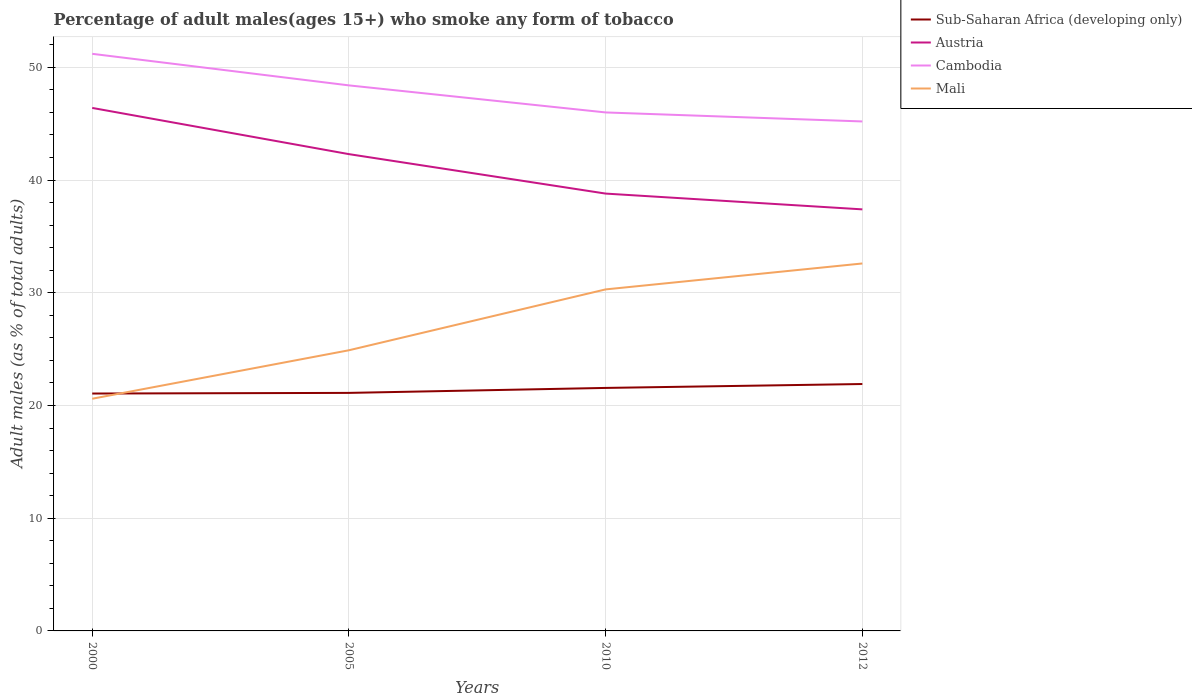Does the line corresponding to Mali intersect with the line corresponding to Cambodia?
Provide a short and direct response. No. Across all years, what is the maximum percentage of adult males who smoke in Sub-Saharan Africa (developing only)?
Ensure brevity in your answer.  21.06. What is the difference between the highest and the second highest percentage of adult males who smoke in Mali?
Ensure brevity in your answer.  12. What is the difference between two consecutive major ticks on the Y-axis?
Offer a very short reply. 10. Are the values on the major ticks of Y-axis written in scientific E-notation?
Offer a very short reply. No. Does the graph contain any zero values?
Your response must be concise. No. How many legend labels are there?
Ensure brevity in your answer.  4. What is the title of the graph?
Offer a very short reply. Percentage of adult males(ages 15+) who smoke any form of tobacco. What is the label or title of the Y-axis?
Give a very brief answer. Adult males (as % of total adults). What is the Adult males (as % of total adults) of Sub-Saharan Africa (developing only) in 2000?
Offer a terse response. 21.06. What is the Adult males (as % of total adults) in Austria in 2000?
Offer a terse response. 46.4. What is the Adult males (as % of total adults) in Cambodia in 2000?
Provide a succinct answer. 51.2. What is the Adult males (as % of total adults) in Mali in 2000?
Offer a terse response. 20.6. What is the Adult males (as % of total adults) of Sub-Saharan Africa (developing only) in 2005?
Your response must be concise. 21.12. What is the Adult males (as % of total adults) in Austria in 2005?
Offer a very short reply. 42.3. What is the Adult males (as % of total adults) in Cambodia in 2005?
Offer a very short reply. 48.4. What is the Adult males (as % of total adults) of Mali in 2005?
Give a very brief answer. 24.9. What is the Adult males (as % of total adults) of Sub-Saharan Africa (developing only) in 2010?
Make the answer very short. 21.56. What is the Adult males (as % of total adults) of Austria in 2010?
Give a very brief answer. 38.8. What is the Adult males (as % of total adults) in Mali in 2010?
Your answer should be very brief. 30.3. What is the Adult males (as % of total adults) in Sub-Saharan Africa (developing only) in 2012?
Ensure brevity in your answer.  21.91. What is the Adult males (as % of total adults) in Austria in 2012?
Ensure brevity in your answer.  37.4. What is the Adult males (as % of total adults) of Cambodia in 2012?
Your response must be concise. 45.2. What is the Adult males (as % of total adults) of Mali in 2012?
Make the answer very short. 32.6. Across all years, what is the maximum Adult males (as % of total adults) of Sub-Saharan Africa (developing only)?
Keep it short and to the point. 21.91. Across all years, what is the maximum Adult males (as % of total adults) in Austria?
Your response must be concise. 46.4. Across all years, what is the maximum Adult males (as % of total adults) in Cambodia?
Your response must be concise. 51.2. Across all years, what is the maximum Adult males (as % of total adults) in Mali?
Provide a short and direct response. 32.6. Across all years, what is the minimum Adult males (as % of total adults) in Sub-Saharan Africa (developing only)?
Your answer should be compact. 21.06. Across all years, what is the minimum Adult males (as % of total adults) of Austria?
Your response must be concise. 37.4. Across all years, what is the minimum Adult males (as % of total adults) in Cambodia?
Keep it short and to the point. 45.2. Across all years, what is the minimum Adult males (as % of total adults) of Mali?
Make the answer very short. 20.6. What is the total Adult males (as % of total adults) in Sub-Saharan Africa (developing only) in the graph?
Offer a very short reply. 85.64. What is the total Adult males (as % of total adults) in Austria in the graph?
Keep it short and to the point. 164.9. What is the total Adult males (as % of total adults) of Cambodia in the graph?
Give a very brief answer. 190.8. What is the total Adult males (as % of total adults) in Mali in the graph?
Offer a terse response. 108.4. What is the difference between the Adult males (as % of total adults) of Sub-Saharan Africa (developing only) in 2000 and that in 2005?
Offer a very short reply. -0.06. What is the difference between the Adult males (as % of total adults) in Cambodia in 2000 and that in 2005?
Offer a very short reply. 2.8. What is the difference between the Adult males (as % of total adults) in Sub-Saharan Africa (developing only) in 2000 and that in 2010?
Give a very brief answer. -0.5. What is the difference between the Adult males (as % of total adults) in Austria in 2000 and that in 2010?
Ensure brevity in your answer.  7.6. What is the difference between the Adult males (as % of total adults) of Cambodia in 2000 and that in 2010?
Ensure brevity in your answer.  5.2. What is the difference between the Adult males (as % of total adults) of Sub-Saharan Africa (developing only) in 2000 and that in 2012?
Offer a terse response. -0.85. What is the difference between the Adult males (as % of total adults) in Cambodia in 2000 and that in 2012?
Give a very brief answer. 6. What is the difference between the Adult males (as % of total adults) in Sub-Saharan Africa (developing only) in 2005 and that in 2010?
Give a very brief answer. -0.44. What is the difference between the Adult males (as % of total adults) of Mali in 2005 and that in 2010?
Keep it short and to the point. -5.4. What is the difference between the Adult males (as % of total adults) in Sub-Saharan Africa (developing only) in 2005 and that in 2012?
Provide a short and direct response. -0.79. What is the difference between the Adult males (as % of total adults) in Austria in 2005 and that in 2012?
Make the answer very short. 4.9. What is the difference between the Adult males (as % of total adults) of Cambodia in 2005 and that in 2012?
Your answer should be very brief. 3.2. What is the difference between the Adult males (as % of total adults) in Mali in 2005 and that in 2012?
Keep it short and to the point. -7.7. What is the difference between the Adult males (as % of total adults) of Sub-Saharan Africa (developing only) in 2010 and that in 2012?
Offer a terse response. -0.35. What is the difference between the Adult males (as % of total adults) of Cambodia in 2010 and that in 2012?
Ensure brevity in your answer.  0.8. What is the difference between the Adult males (as % of total adults) of Sub-Saharan Africa (developing only) in 2000 and the Adult males (as % of total adults) of Austria in 2005?
Your response must be concise. -21.24. What is the difference between the Adult males (as % of total adults) of Sub-Saharan Africa (developing only) in 2000 and the Adult males (as % of total adults) of Cambodia in 2005?
Offer a terse response. -27.34. What is the difference between the Adult males (as % of total adults) in Sub-Saharan Africa (developing only) in 2000 and the Adult males (as % of total adults) in Mali in 2005?
Give a very brief answer. -3.84. What is the difference between the Adult males (as % of total adults) in Cambodia in 2000 and the Adult males (as % of total adults) in Mali in 2005?
Offer a terse response. 26.3. What is the difference between the Adult males (as % of total adults) in Sub-Saharan Africa (developing only) in 2000 and the Adult males (as % of total adults) in Austria in 2010?
Offer a terse response. -17.74. What is the difference between the Adult males (as % of total adults) of Sub-Saharan Africa (developing only) in 2000 and the Adult males (as % of total adults) of Cambodia in 2010?
Your answer should be compact. -24.94. What is the difference between the Adult males (as % of total adults) in Sub-Saharan Africa (developing only) in 2000 and the Adult males (as % of total adults) in Mali in 2010?
Offer a terse response. -9.24. What is the difference between the Adult males (as % of total adults) of Cambodia in 2000 and the Adult males (as % of total adults) of Mali in 2010?
Offer a terse response. 20.9. What is the difference between the Adult males (as % of total adults) of Sub-Saharan Africa (developing only) in 2000 and the Adult males (as % of total adults) of Austria in 2012?
Offer a very short reply. -16.34. What is the difference between the Adult males (as % of total adults) of Sub-Saharan Africa (developing only) in 2000 and the Adult males (as % of total adults) of Cambodia in 2012?
Your answer should be compact. -24.14. What is the difference between the Adult males (as % of total adults) of Sub-Saharan Africa (developing only) in 2000 and the Adult males (as % of total adults) of Mali in 2012?
Offer a very short reply. -11.54. What is the difference between the Adult males (as % of total adults) in Austria in 2000 and the Adult males (as % of total adults) in Cambodia in 2012?
Give a very brief answer. 1.2. What is the difference between the Adult males (as % of total adults) in Austria in 2000 and the Adult males (as % of total adults) in Mali in 2012?
Keep it short and to the point. 13.8. What is the difference between the Adult males (as % of total adults) of Cambodia in 2000 and the Adult males (as % of total adults) of Mali in 2012?
Provide a short and direct response. 18.6. What is the difference between the Adult males (as % of total adults) of Sub-Saharan Africa (developing only) in 2005 and the Adult males (as % of total adults) of Austria in 2010?
Offer a terse response. -17.68. What is the difference between the Adult males (as % of total adults) in Sub-Saharan Africa (developing only) in 2005 and the Adult males (as % of total adults) in Cambodia in 2010?
Keep it short and to the point. -24.88. What is the difference between the Adult males (as % of total adults) of Sub-Saharan Africa (developing only) in 2005 and the Adult males (as % of total adults) of Mali in 2010?
Your answer should be very brief. -9.18. What is the difference between the Adult males (as % of total adults) in Austria in 2005 and the Adult males (as % of total adults) in Cambodia in 2010?
Offer a terse response. -3.7. What is the difference between the Adult males (as % of total adults) in Austria in 2005 and the Adult males (as % of total adults) in Mali in 2010?
Offer a very short reply. 12. What is the difference between the Adult males (as % of total adults) of Sub-Saharan Africa (developing only) in 2005 and the Adult males (as % of total adults) of Austria in 2012?
Provide a succinct answer. -16.28. What is the difference between the Adult males (as % of total adults) in Sub-Saharan Africa (developing only) in 2005 and the Adult males (as % of total adults) in Cambodia in 2012?
Your answer should be very brief. -24.08. What is the difference between the Adult males (as % of total adults) of Sub-Saharan Africa (developing only) in 2005 and the Adult males (as % of total adults) of Mali in 2012?
Provide a succinct answer. -11.48. What is the difference between the Adult males (as % of total adults) in Cambodia in 2005 and the Adult males (as % of total adults) in Mali in 2012?
Your answer should be very brief. 15.8. What is the difference between the Adult males (as % of total adults) in Sub-Saharan Africa (developing only) in 2010 and the Adult males (as % of total adults) in Austria in 2012?
Your response must be concise. -15.84. What is the difference between the Adult males (as % of total adults) of Sub-Saharan Africa (developing only) in 2010 and the Adult males (as % of total adults) of Cambodia in 2012?
Offer a very short reply. -23.64. What is the difference between the Adult males (as % of total adults) of Sub-Saharan Africa (developing only) in 2010 and the Adult males (as % of total adults) of Mali in 2012?
Your answer should be very brief. -11.04. What is the difference between the Adult males (as % of total adults) in Cambodia in 2010 and the Adult males (as % of total adults) in Mali in 2012?
Offer a very short reply. 13.4. What is the average Adult males (as % of total adults) of Sub-Saharan Africa (developing only) per year?
Provide a succinct answer. 21.41. What is the average Adult males (as % of total adults) of Austria per year?
Offer a terse response. 41.23. What is the average Adult males (as % of total adults) in Cambodia per year?
Provide a short and direct response. 47.7. What is the average Adult males (as % of total adults) of Mali per year?
Keep it short and to the point. 27.1. In the year 2000, what is the difference between the Adult males (as % of total adults) of Sub-Saharan Africa (developing only) and Adult males (as % of total adults) of Austria?
Your answer should be compact. -25.34. In the year 2000, what is the difference between the Adult males (as % of total adults) of Sub-Saharan Africa (developing only) and Adult males (as % of total adults) of Cambodia?
Your answer should be compact. -30.14. In the year 2000, what is the difference between the Adult males (as % of total adults) in Sub-Saharan Africa (developing only) and Adult males (as % of total adults) in Mali?
Provide a succinct answer. 0.46. In the year 2000, what is the difference between the Adult males (as % of total adults) of Austria and Adult males (as % of total adults) of Cambodia?
Keep it short and to the point. -4.8. In the year 2000, what is the difference between the Adult males (as % of total adults) in Austria and Adult males (as % of total adults) in Mali?
Provide a succinct answer. 25.8. In the year 2000, what is the difference between the Adult males (as % of total adults) in Cambodia and Adult males (as % of total adults) in Mali?
Provide a succinct answer. 30.6. In the year 2005, what is the difference between the Adult males (as % of total adults) in Sub-Saharan Africa (developing only) and Adult males (as % of total adults) in Austria?
Your answer should be compact. -21.18. In the year 2005, what is the difference between the Adult males (as % of total adults) of Sub-Saharan Africa (developing only) and Adult males (as % of total adults) of Cambodia?
Ensure brevity in your answer.  -27.28. In the year 2005, what is the difference between the Adult males (as % of total adults) of Sub-Saharan Africa (developing only) and Adult males (as % of total adults) of Mali?
Keep it short and to the point. -3.78. In the year 2005, what is the difference between the Adult males (as % of total adults) in Austria and Adult males (as % of total adults) in Cambodia?
Your response must be concise. -6.1. In the year 2005, what is the difference between the Adult males (as % of total adults) of Austria and Adult males (as % of total adults) of Mali?
Offer a very short reply. 17.4. In the year 2005, what is the difference between the Adult males (as % of total adults) of Cambodia and Adult males (as % of total adults) of Mali?
Ensure brevity in your answer.  23.5. In the year 2010, what is the difference between the Adult males (as % of total adults) in Sub-Saharan Africa (developing only) and Adult males (as % of total adults) in Austria?
Your response must be concise. -17.24. In the year 2010, what is the difference between the Adult males (as % of total adults) in Sub-Saharan Africa (developing only) and Adult males (as % of total adults) in Cambodia?
Offer a very short reply. -24.44. In the year 2010, what is the difference between the Adult males (as % of total adults) in Sub-Saharan Africa (developing only) and Adult males (as % of total adults) in Mali?
Ensure brevity in your answer.  -8.74. In the year 2010, what is the difference between the Adult males (as % of total adults) of Austria and Adult males (as % of total adults) of Mali?
Provide a succinct answer. 8.5. In the year 2010, what is the difference between the Adult males (as % of total adults) of Cambodia and Adult males (as % of total adults) of Mali?
Provide a short and direct response. 15.7. In the year 2012, what is the difference between the Adult males (as % of total adults) of Sub-Saharan Africa (developing only) and Adult males (as % of total adults) of Austria?
Provide a succinct answer. -15.49. In the year 2012, what is the difference between the Adult males (as % of total adults) of Sub-Saharan Africa (developing only) and Adult males (as % of total adults) of Cambodia?
Your response must be concise. -23.29. In the year 2012, what is the difference between the Adult males (as % of total adults) in Sub-Saharan Africa (developing only) and Adult males (as % of total adults) in Mali?
Your answer should be very brief. -10.69. In the year 2012, what is the difference between the Adult males (as % of total adults) of Cambodia and Adult males (as % of total adults) of Mali?
Your response must be concise. 12.6. What is the ratio of the Adult males (as % of total adults) in Sub-Saharan Africa (developing only) in 2000 to that in 2005?
Your response must be concise. 1. What is the ratio of the Adult males (as % of total adults) of Austria in 2000 to that in 2005?
Offer a very short reply. 1.1. What is the ratio of the Adult males (as % of total adults) in Cambodia in 2000 to that in 2005?
Provide a short and direct response. 1.06. What is the ratio of the Adult males (as % of total adults) in Mali in 2000 to that in 2005?
Give a very brief answer. 0.83. What is the ratio of the Adult males (as % of total adults) of Sub-Saharan Africa (developing only) in 2000 to that in 2010?
Keep it short and to the point. 0.98. What is the ratio of the Adult males (as % of total adults) of Austria in 2000 to that in 2010?
Offer a terse response. 1.2. What is the ratio of the Adult males (as % of total adults) of Cambodia in 2000 to that in 2010?
Give a very brief answer. 1.11. What is the ratio of the Adult males (as % of total adults) in Mali in 2000 to that in 2010?
Offer a terse response. 0.68. What is the ratio of the Adult males (as % of total adults) of Sub-Saharan Africa (developing only) in 2000 to that in 2012?
Ensure brevity in your answer.  0.96. What is the ratio of the Adult males (as % of total adults) of Austria in 2000 to that in 2012?
Provide a short and direct response. 1.24. What is the ratio of the Adult males (as % of total adults) in Cambodia in 2000 to that in 2012?
Keep it short and to the point. 1.13. What is the ratio of the Adult males (as % of total adults) in Mali in 2000 to that in 2012?
Provide a succinct answer. 0.63. What is the ratio of the Adult males (as % of total adults) of Sub-Saharan Africa (developing only) in 2005 to that in 2010?
Ensure brevity in your answer.  0.98. What is the ratio of the Adult males (as % of total adults) of Austria in 2005 to that in 2010?
Provide a short and direct response. 1.09. What is the ratio of the Adult males (as % of total adults) in Cambodia in 2005 to that in 2010?
Offer a terse response. 1.05. What is the ratio of the Adult males (as % of total adults) of Mali in 2005 to that in 2010?
Keep it short and to the point. 0.82. What is the ratio of the Adult males (as % of total adults) in Sub-Saharan Africa (developing only) in 2005 to that in 2012?
Provide a succinct answer. 0.96. What is the ratio of the Adult males (as % of total adults) in Austria in 2005 to that in 2012?
Your response must be concise. 1.13. What is the ratio of the Adult males (as % of total adults) of Cambodia in 2005 to that in 2012?
Ensure brevity in your answer.  1.07. What is the ratio of the Adult males (as % of total adults) in Mali in 2005 to that in 2012?
Offer a terse response. 0.76. What is the ratio of the Adult males (as % of total adults) of Sub-Saharan Africa (developing only) in 2010 to that in 2012?
Give a very brief answer. 0.98. What is the ratio of the Adult males (as % of total adults) of Austria in 2010 to that in 2012?
Provide a succinct answer. 1.04. What is the ratio of the Adult males (as % of total adults) in Cambodia in 2010 to that in 2012?
Your response must be concise. 1.02. What is the ratio of the Adult males (as % of total adults) of Mali in 2010 to that in 2012?
Make the answer very short. 0.93. What is the difference between the highest and the second highest Adult males (as % of total adults) in Sub-Saharan Africa (developing only)?
Ensure brevity in your answer.  0.35. What is the difference between the highest and the second highest Adult males (as % of total adults) in Austria?
Offer a terse response. 4.1. What is the difference between the highest and the second highest Adult males (as % of total adults) in Mali?
Your answer should be compact. 2.3. What is the difference between the highest and the lowest Adult males (as % of total adults) in Sub-Saharan Africa (developing only)?
Give a very brief answer. 0.85. What is the difference between the highest and the lowest Adult males (as % of total adults) of Cambodia?
Your answer should be very brief. 6. 